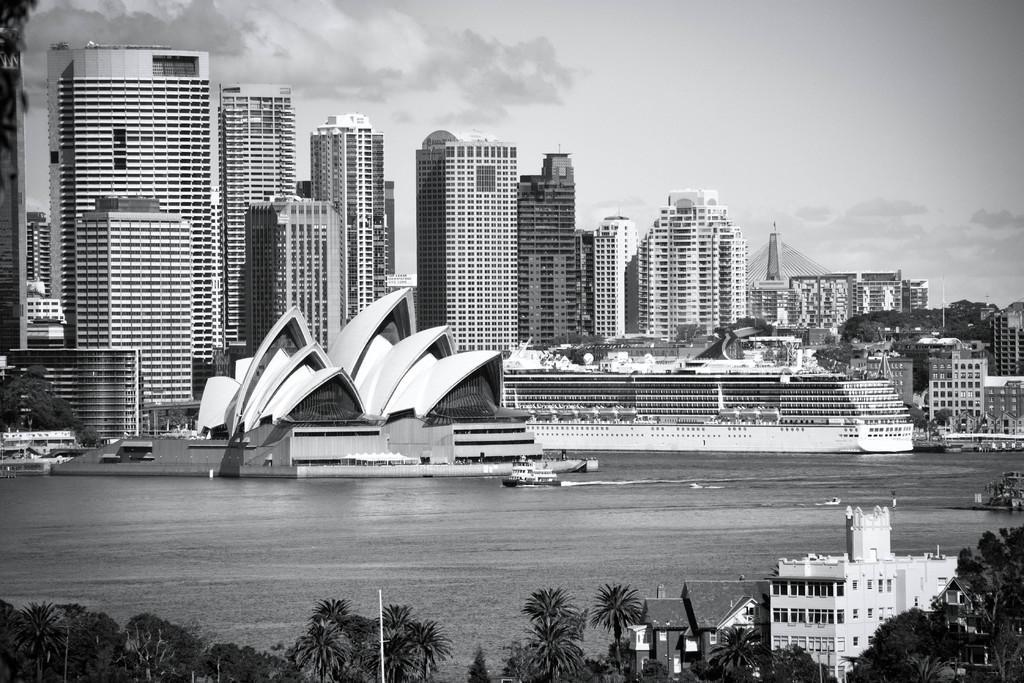Could you give a brief overview of what you see in this image? In this image I can see the water, a boat in the water, few trees and few buildings. In the background I can see few buildings, few trees and the sky. 